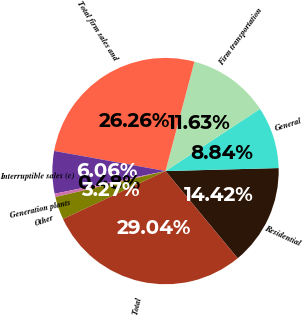Convert chart. <chart><loc_0><loc_0><loc_500><loc_500><pie_chart><fcel>Residential<fcel>General<fcel>Firm transportation<fcel>Total firm sales and<fcel>Interruptible sales (c)<fcel>Generation plants<fcel>Other<fcel>Total<nl><fcel>14.42%<fcel>8.84%<fcel>11.63%<fcel>26.26%<fcel>6.06%<fcel>0.48%<fcel>3.27%<fcel>29.04%<nl></chart> 